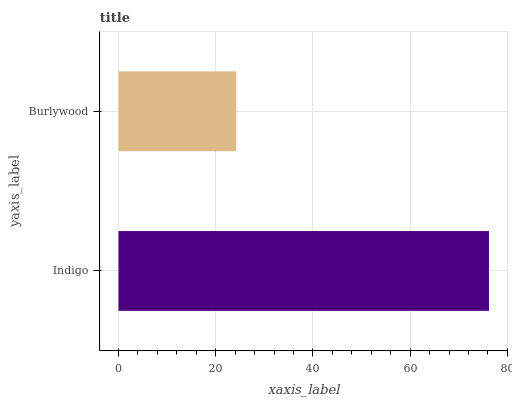Is Burlywood the minimum?
Answer yes or no. Yes. Is Indigo the maximum?
Answer yes or no. Yes. Is Burlywood the maximum?
Answer yes or no. No. Is Indigo greater than Burlywood?
Answer yes or no. Yes. Is Burlywood less than Indigo?
Answer yes or no. Yes. Is Burlywood greater than Indigo?
Answer yes or no. No. Is Indigo less than Burlywood?
Answer yes or no. No. Is Indigo the high median?
Answer yes or no. Yes. Is Burlywood the low median?
Answer yes or no. Yes. Is Burlywood the high median?
Answer yes or no. No. Is Indigo the low median?
Answer yes or no. No. 